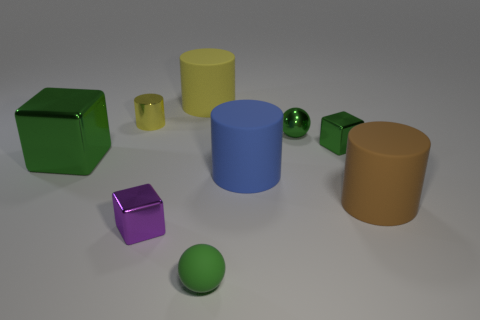What material is the small green ball in front of the block that is right of the big thing that is behind the tiny green block?
Provide a short and direct response. Rubber. Does the large blue thing have the same material as the tiny cube that is on the right side of the yellow rubber thing?
Your answer should be very brief. No. What is the material of the big yellow object that is the same shape as the small yellow thing?
Make the answer very short. Rubber. Are there any other things that have the same material as the large brown cylinder?
Provide a short and direct response. Yes. Is the number of green matte spheres right of the tiny green shiny block greater than the number of metal things that are behind the yellow shiny cylinder?
Keep it short and to the point. No. There is a purple object that is made of the same material as the tiny green cube; what shape is it?
Keep it short and to the point. Cube. What number of other things are there of the same shape as the purple thing?
Provide a succinct answer. 2. What is the shape of the rubber thing left of the small rubber object?
Make the answer very short. Cylinder. What color is the tiny cylinder?
Offer a terse response. Yellow. How many other objects are the same size as the yellow metal cylinder?
Keep it short and to the point. 4. 